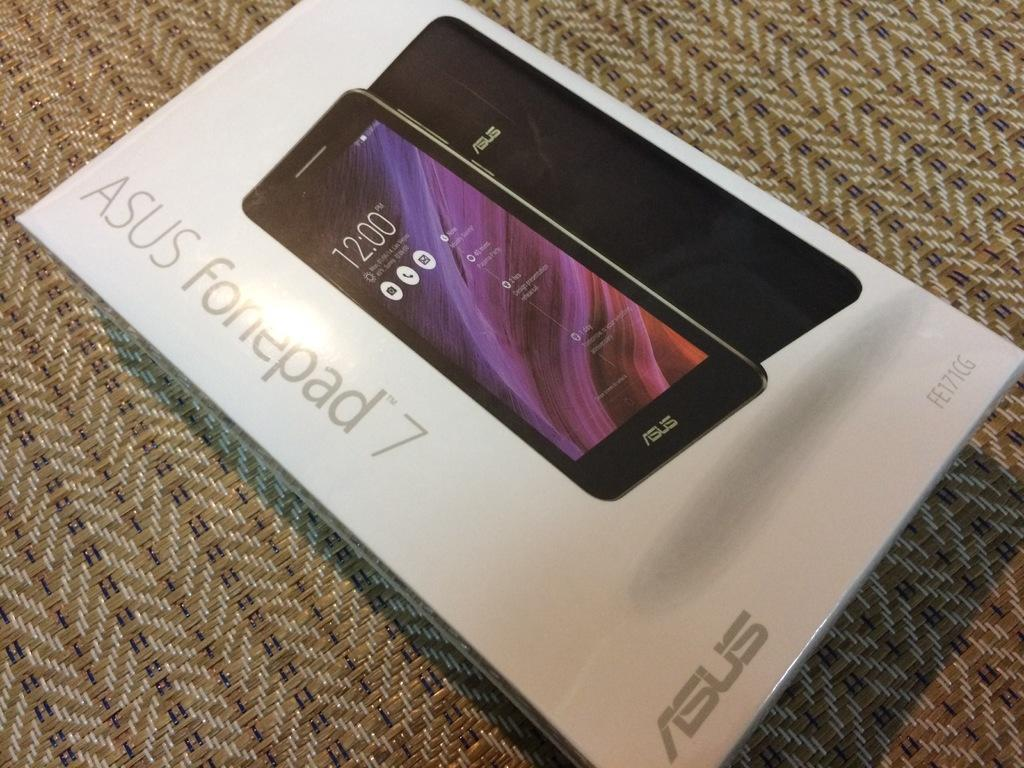<image>
Describe the image concisely. A box of a Asus Fonepad 7 laying on a carpet. 